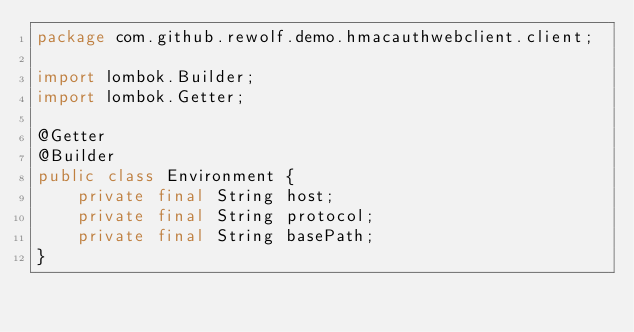<code> <loc_0><loc_0><loc_500><loc_500><_Java_>package com.github.rewolf.demo.hmacauthwebclient.client;

import lombok.Builder;
import lombok.Getter;

@Getter
@Builder
public class Environment {
    private final String host;
    private final String protocol;
    private final String basePath;
}
</code> 